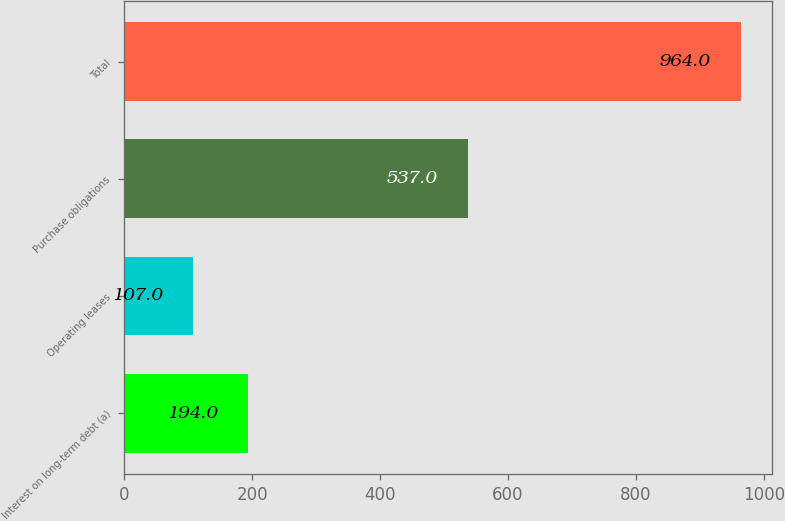<chart> <loc_0><loc_0><loc_500><loc_500><bar_chart><fcel>Interest on long-term debt (a)<fcel>Operating leases<fcel>Purchase obligations<fcel>Total<nl><fcel>194<fcel>107<fcel>537<fcel>964<nl></chart> 